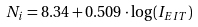Convert formula to latex. <formula><loc_0><loc_0><loc_500><loc_500>N _ { i } = 8 . 3 4 + 0 . 5 0 9 \cdot \log ( I _ { E I T } )</formula> 